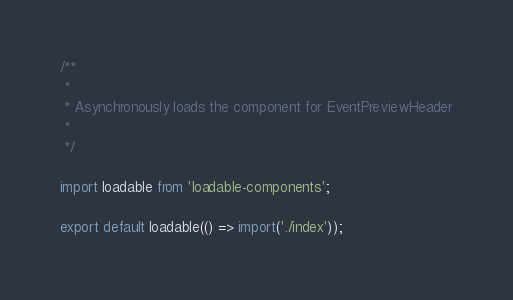Convert code to text. <code><loc_0><loc_0><loc_500><loc_500><_JavaScript_>/**
 *
 * Asynchronously loads the component for EventPreviewHeader
 *
 */

import loadable from 'loadable-components';

export default loadable(() => import('./index'));
</code> 